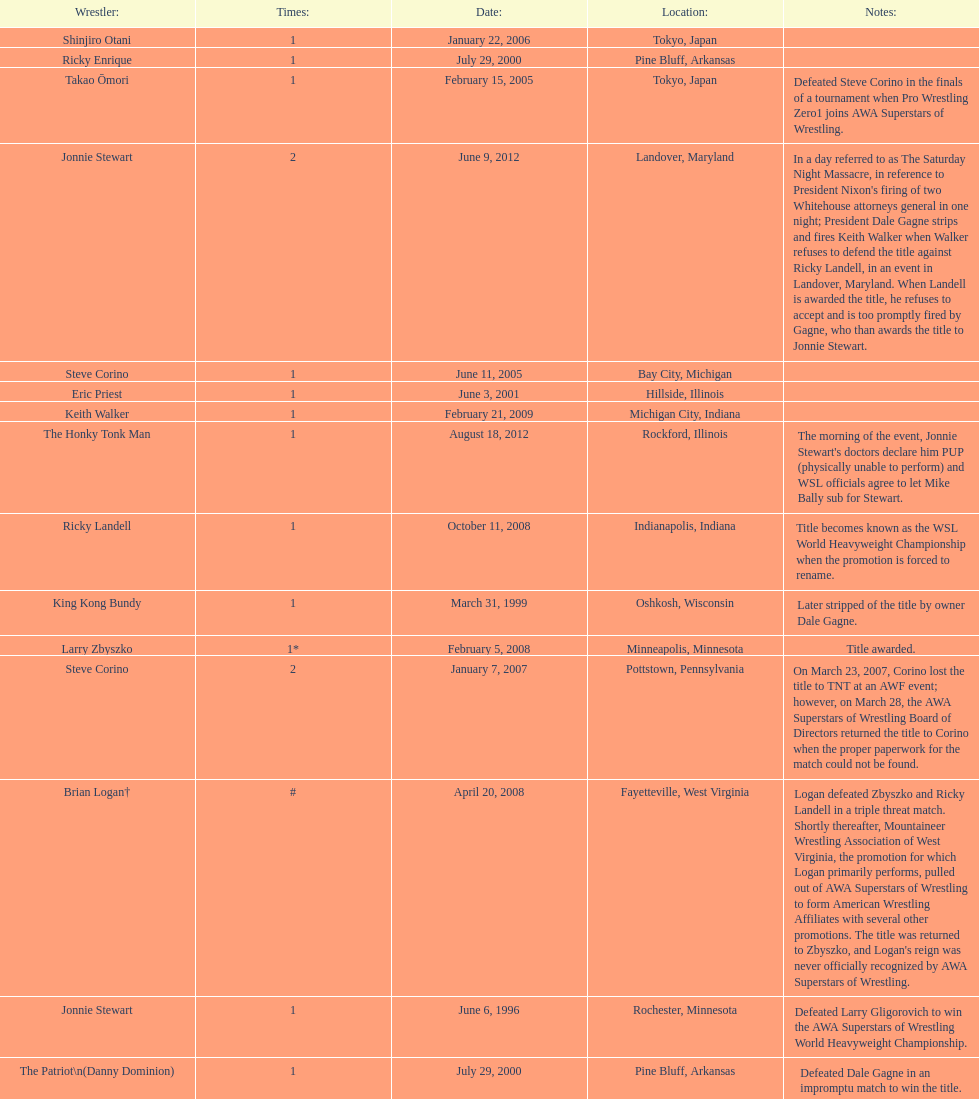The patriot (danny dominion) won the title from what previous holder through an impromptu match? Dale Gagne. 